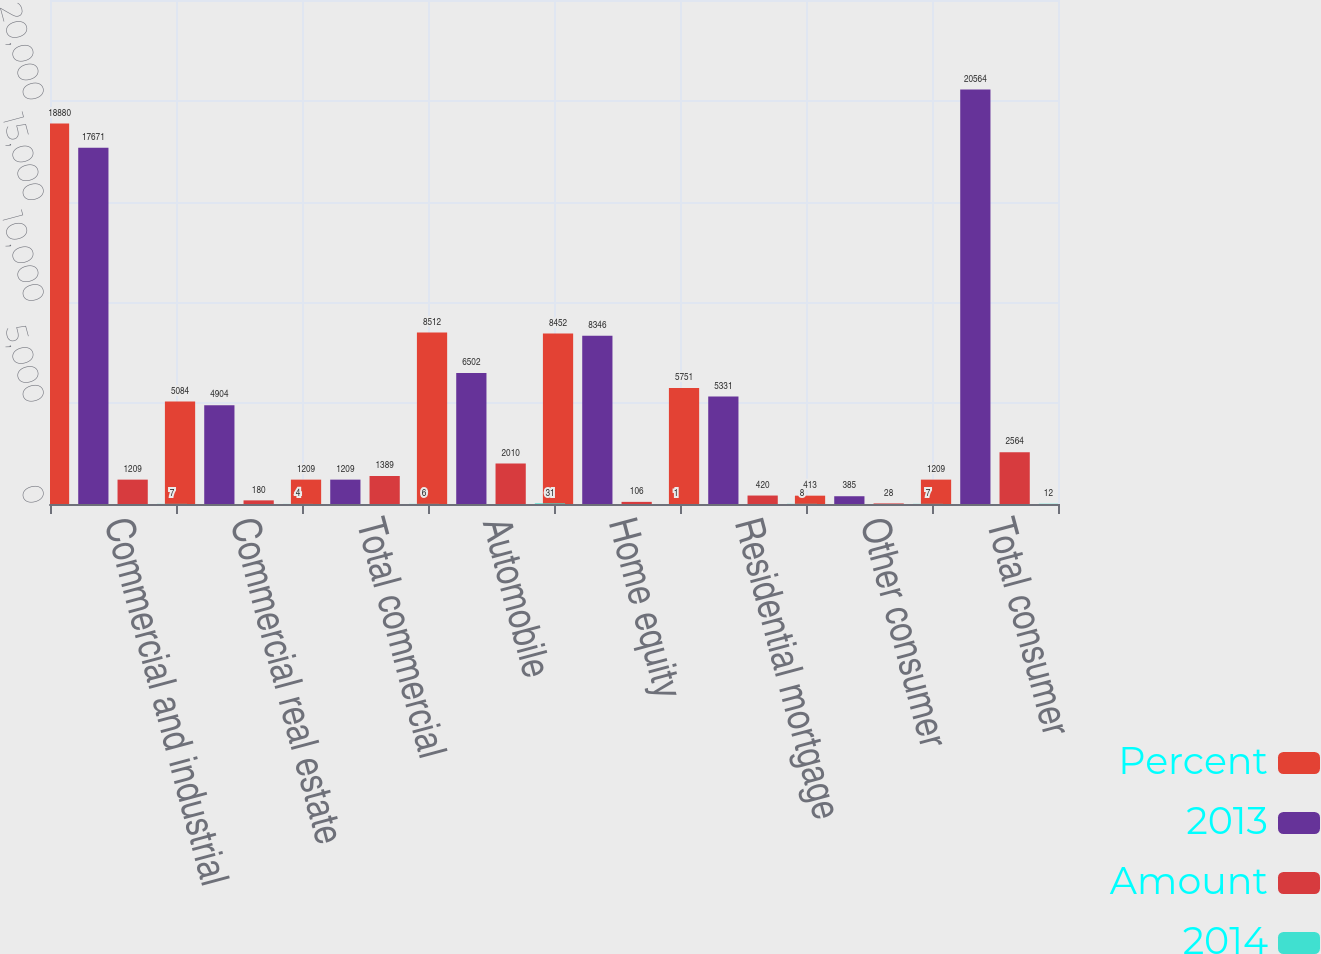Convert chart. <chart><loc_0><loc_0><loc_500><loc_500><stacked_bar_chart><ecel><fcel>Commercial and industrial<fcel>Commercial real estate<fcel>Total commercial<fcel>Automobile<fcel>Home equity<fcel>Residential mortgage<fcel>Other consumer<fcel>Total consumer<nl><fcel>Percent<fcel>18880<fcel>5084<fcel>1209<fcel>8512<fcel>8452<fcel>5751<fcel>413<fcel>1209<nl><fcel>2013<fcel>17671<fcel>4904<fcel>1209<fcel>6502<fcel>8346<fcel>5331<fcel>385<fcel>20564<nl><fcel>Amount<fcel>1209<fcel>180<fcel>1389<fcel>2010<fcel>106<fcel>420<fcel>28<fcel>2564<nl><fcel>2014<fcel>7<fcel>4<fcel>6<fcel>31<fcel>1<fcel>8<fcel>7<fcel>12<nl></chart> 